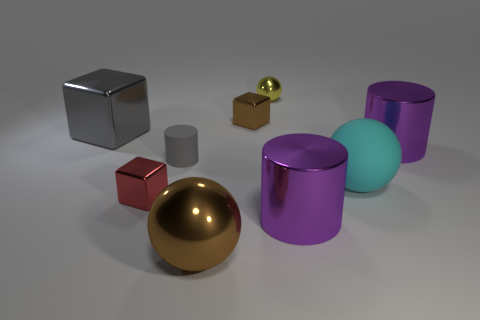Add 1 cyan matte objects. How many objects exist? 10 Subtract all cylinders. How many objects are left? 6 Add 8 brown shiny blocks. How many brown shiny blocks exist? 9 Subtract 0 blue cubes. How many objects are left? 9 Subtract all cyan matte objects. Subtract all purple things. How many objects are left? 6 Add 1 big gray metallic cubes. How many big gray metallic cubes are left? 2 